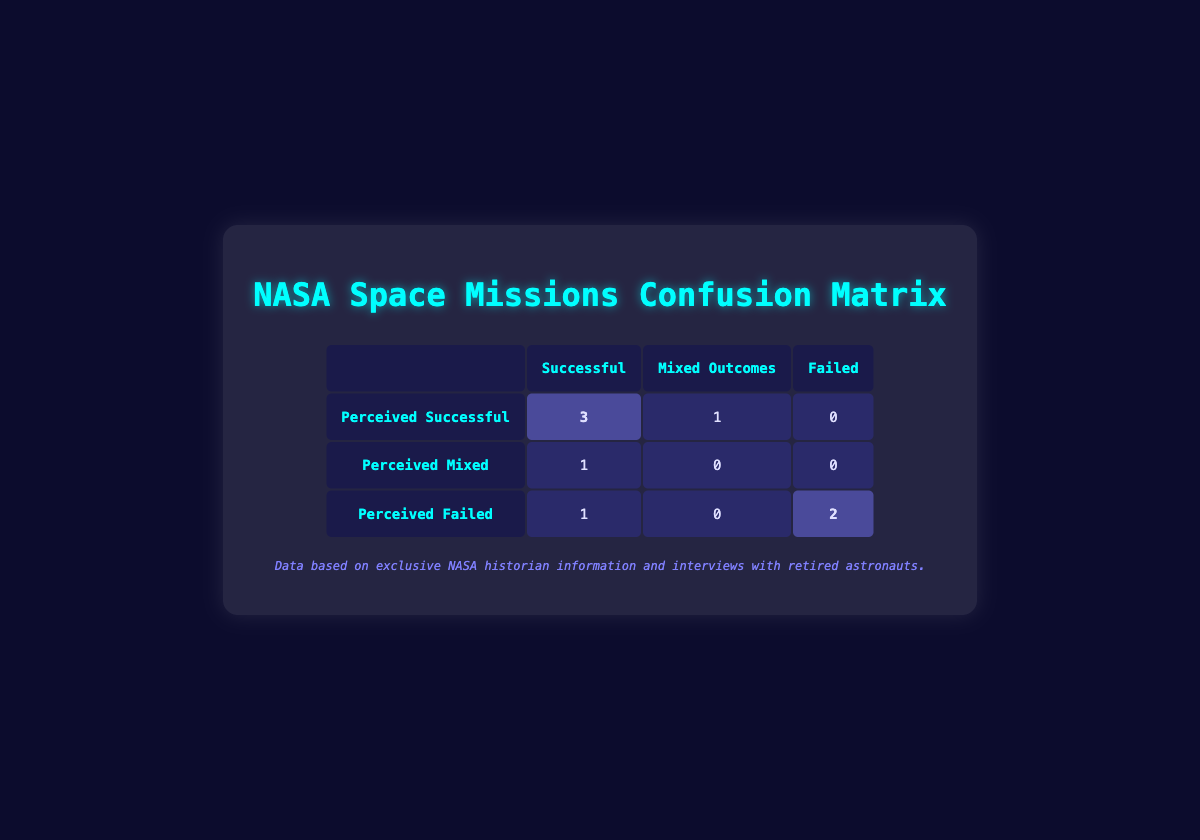What is the number of missions perceived as successful that actually were successful? From the table, we see the "Perceived Successful" row and look for the "Successful" column. The first cell contains the count of 3, indicating that three missions, perceived as successful, also had successful outcomes.
Answer: 3 How many missions were perceived as failed? By looking at the "Perceived Failed" row, we see that the total count for that row is the sum of its three columns. For the 'Successful' column, there is 1, for the 'Mixed Outcomes' column, there is 0, and for the 'Failed' column, there are 2. Thus, 1 + 0 + 2 = 3.
Answer: 3 Is it true that there are no missions perceived as failed that were successful? We check the "Perceived Failed" row and see how many successes are in that row. The count in the 'Successful' column is 1, which indicates there was one mission perceived as failed that was actually successful. Thus, the statement is false.
Answer: No What percentage of missions were both perceived and actual successes? To find the percentage of missions that were both perceived and actual successes, we look at the total number of missions. There are 8 missions in total. The count for perceived and actual successes is 3. Thus, (3/8) * 100 = 37.5%.
Answer: 37.5% How many missions had mixed outcomes and were perceived as successful? In the "Perceived Mixed" row and the "Mixed Outcomes" column, checking the values indicates that there are no counts; hence, the number of missions with mixed outcomes that were perceived as successful is 0.
Answer: 0 What is the total number of perceived successes comparing to perceived failures? We need to sum the totals for perceived successes and perceived failures. The total for perceived successful (3 for actual success, 1 for mixed, and 0 for failed) equals 4. For perceived failed missions, (1 for actual success, 0 for mixed, and 2 for failed) equals 3. Thus, comparing gives 4 - 3 = 1 more perceived successful than failed.
Answer: 1 How many missions had a mixed actual outcome while being perceived as highly successful? We check the rows for perceived successful to see if there are any counts in the mixed outcomes and find that there is 1. Hence, there was one mission that matches these criteria.
Answer: 1 